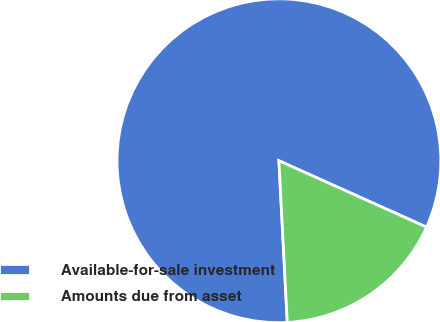Convert chart to OTSL. <chart><loc_0><loc_0><loc_500><loc_500><pie_chart><fcel>Available-for-sale investment<fcel>Amounts due from asset<nl><fcel>82.55%<fcel>17.45%<nl></chart> 